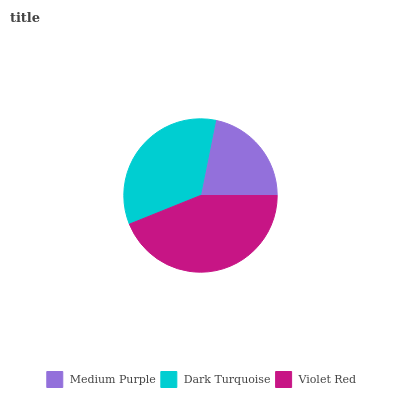Is Medium Purple the minimum?
Answer yes or no. Yes. Is Violet Red the maximum?
Answer yes or no. Yes. Is Dark Turquoise the minimum?
Answer yes or no. No. Is Dark Turquoise the maximum?
Answer yes or no. No. Is Dark Turquoise greater than Medium Purple?
Answer yes or no. Yes. Is Medium Purple less than Dark Turquoise?
Answer yes or no. Yes. Is Medium Purple greater than Dark Turquoise?
Answer yes or no. No. Is Dark Turquoise less than Medium Purple?
Answer yes or no. No. Is Dark Turquoise the high median?
Answer yes or no. Yes. Is Dark Turquoise the low median?
Answer yes or no. Yes. Is Violet Red the high median?
Answer yes or no. No. Is Violet Red the low median?
Answer yes or no. No. 